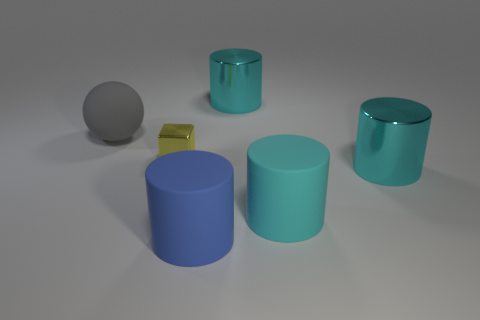What number of balls are big matte things or tiny objects? In the image, there is a single ball that can be considered a tiny object, specifically a small gray sphere. There are no big matte balls present. Additionally, there are various other objects, including cylinders and a cube, but they do not match the criteria of big matte balls. 